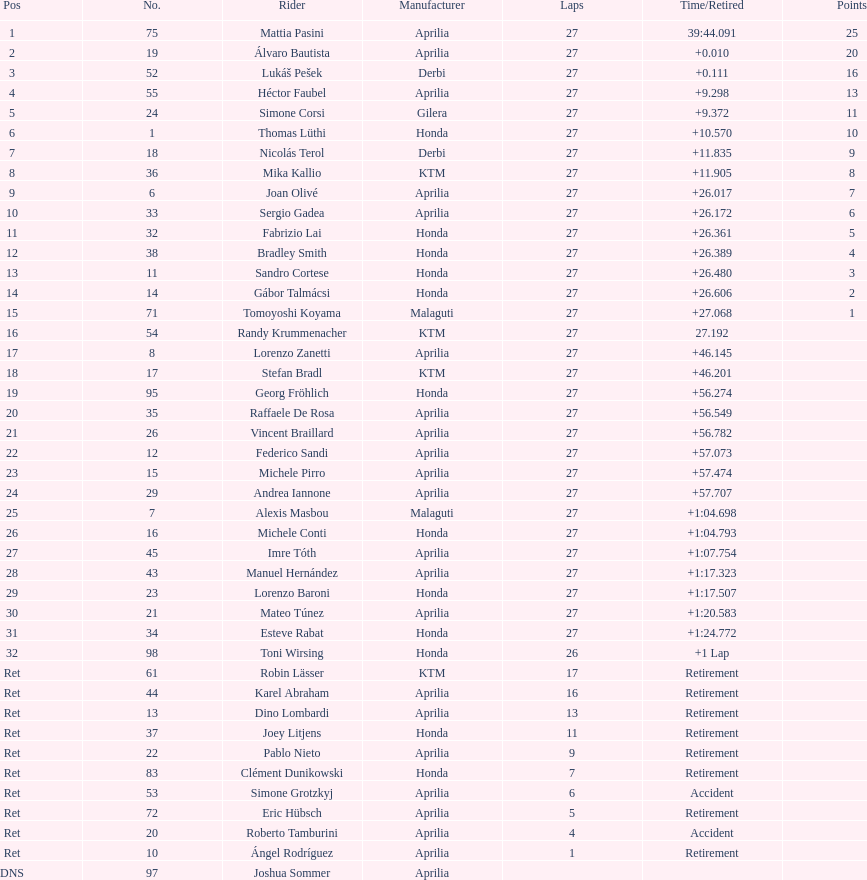Who placed higher, bradl or gadea? Sergio Gadea. 